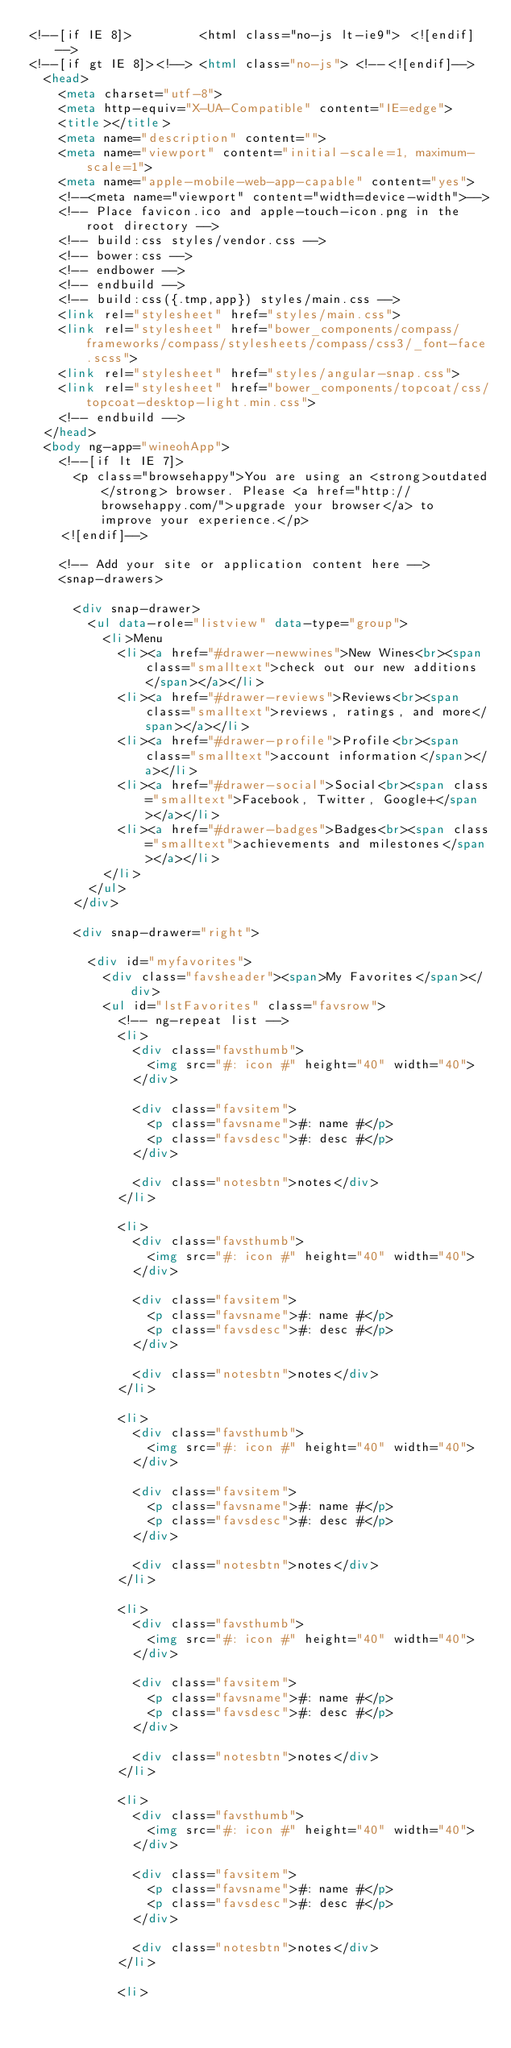Convert code to text. <code><loc_0><loc_0><loc_500><loc_500><_HTML_><!--[if IE 8]>         <html class="no-js lt-ie9"> <![endif]-->
<!--[if gt IE 8]><!--> <html class="no-js"> <!--<![endif]-->
  <head>
    <meta charset="utf-8">
    <meta http-equiv="X-UA-Compatible" content="IE=edge">
    <title></title>
    <meta name="description" content="">
    <meta name="viewport" content="initial-scale=1, maximum-scale=1">
    <meta name="apple-mobile-web-app-capable" content="yes">
    <!--<meta name="viewport" content="width=device-width">-->
    <!-- Place favicon.ico and apple-touch-icon.png in the root directory -->
    <!-- build:css styles/vendor.css -->
    <!-- bower:css -->
    <!-- endbower -->
    <!-- endbuild -->
    <!-- build:css({.tmp,app}) styles/main.css -->
    <link rel="stylesheet" href="styles/main.css">
    <link rel="stylesheet" href="bower_components/compass/frameworks/compass/stylesheets/compass/css3/_font-face.scss">
    <link rel="stylesheet" href="styles/angular-snap.css">
    <link rel="stylesheet" href="bower_components/topcoat/css/topcoat-desktop-light.min.css">
    <!-- endbuild -->
  </head>
  <body ng-app="wineohApp">
    <!--[if lt IE 7]>
      <p class="browsehappy">You are using an <strong>outdated</strong> browser. Please <a href="http://browsehappy.com/">upgrade your browser</a> to improve your experience.</p>
    <![endif]-->

    <!-- Add your site or application content here -->
    <snap-drawers>

      <div snap-drawer>
        <ul data-role="listview" data-type="group">
          <li>Menu
            <li><a href="#drawer-newwines">New Wines<br><span class="smalltext">check out our new additions</span></a></li>
            <li><a href="#drawer-reviews">Reviews<br><span class="smalltext">reviews, ratings, and more</span></a></li>
            <li><a href="#drawer-profile">Profile<br><span class="smalltext">account information</span></a></li>
            <li><a href="#drawer-social">Social<br><span class="smalltext">Facebook, Twitter, Google+</span></a></li>
            <li><a href="#drawer-badges">Badges<br><span class="smalltext">achievements and milestones</span></a></li>
          </li>
        </ul>
      </div>

      <div snap-drawer="right">

        <div id="myfavorites">
          <div class="favsheader"><span>My Favorites</span></div>
          <ul id="lstFavorites" class="favsrow">
            <!-- ng-repeat list -->
            <li>
              <div class="favsthumb">
                <img src="#: icon #" height="40" width="40">
              </div>

              <div class="favsitem">
                <p class="favsname">#: name #</p>
                <p class="favsdesc">#: desc #</p>
              </div>

              <div class="notesbtn">notes</div>
            </li>

            <li>
              <div class="favsthumb">
                <img src="#: icon #" height="40" width="40">
              </div>

              <div class="favsitem">
                <p class="favsname">#: name #</p>
                <p class="favsdesc">#: desc #</p>
              </div>

              <div class="notesbtn">notes</div>
            </li>

            <li>
              <div class="favsthumb">
                <img src="#: icon #" height="40" width="40">
              </div>

              <div class="favsitem">
                <p class="favsname">#: name #</p>
                <p class="favsdesc">#: desc #</p>
              </div>

              <div class="notesbtn">notes</div>
            </li>

            <li>
              <div class="favsthumb">
                <img src="#: icon #" height="40" width="40">
              </div>

              <div class="favsitem">
                <p class="favsname">#: name #</p>
                <p class="favsdesc">#: desc #</p>
              </div>

              <div class="notesbtn">notes</div>
            </li>

            <li>
              <div class="favsthumb">
                <img src="#: icon #" height="40" width="40">
              </div>

              <div class="favsitem">
                <p class="favsname">#: name #</p>
                <p class="favsdesc">#: desc #</p>
              </div>

              <div class="notesbtn">notes</div>
            </li>

            <li></code> 